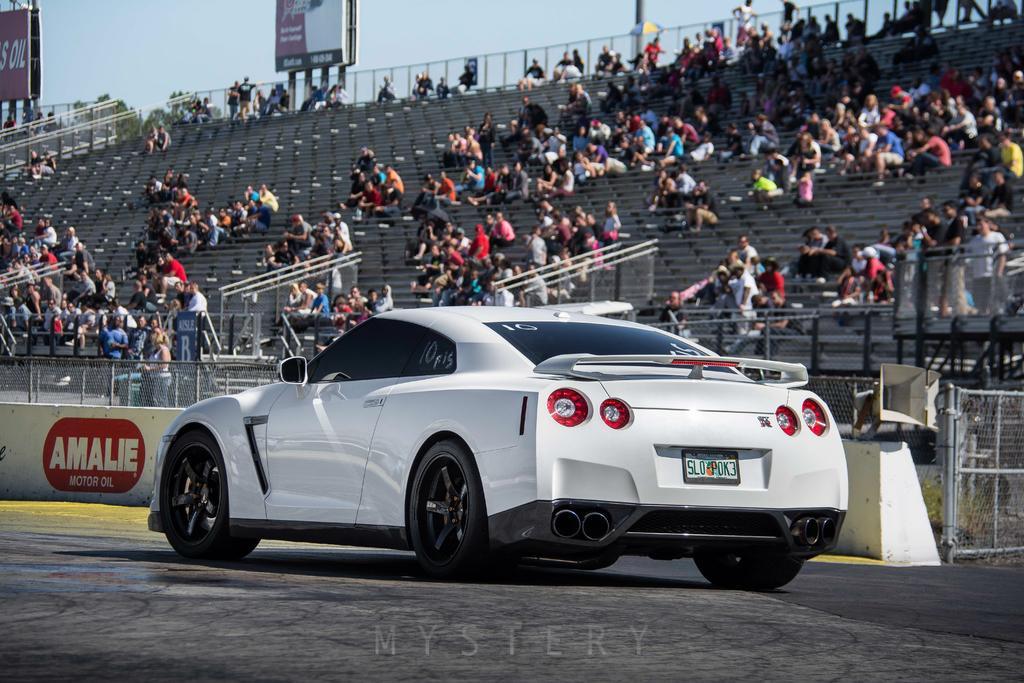Can you describe this image briefly? At the bottom of the image on the road there is a car. Behind the car there is a small wall with mesh fencing. Behind the fencing there are railings and steps. On the steps there are many people sitting. Behind them there is mesh fencing. In the bottom right corner of the image there is a gate. At the top of the image there are banners with text. 